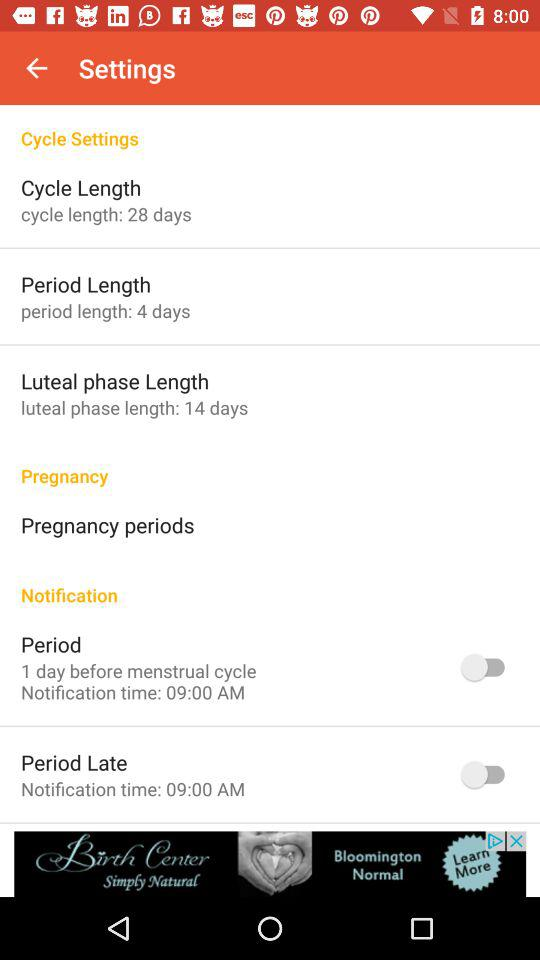What is the notification time for the "Period Late" setting? The notification time for the "Period Late" setting is 9:00 AM. 